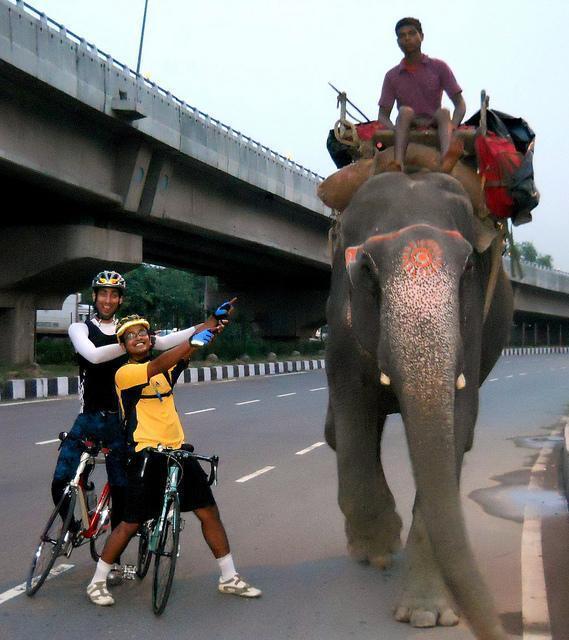How many elephants can be seen?
Give a very brief answer. 1. How many bicycles are in the photo?
Give a very brief answer. 2. How many people can be seen?
Give a very brief answer. 3. How many people are wearing orange shirts?
Give a very brief answer. 0. 